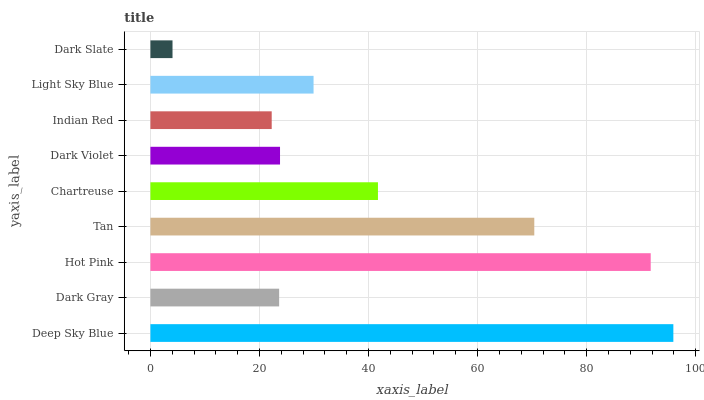Is Dark Slate the minimum?
Answer yes or no. Yes. Is Deep Sky Blue the maximum?
Answer yes or no. Yes. Is Dark Gray the minimum?
Answer yes or no. No. Is Dark Gray the maximum?
Answer yes or no. No. Is Deep Sky Blue greater than Dark Gray?
Answer yes or no. Yes. Is Dark Gray less than Deep Sky Blue?
Answer yes or no. Yes. Is Dark Gray greater than Deep Sky Blue?
Answer yes or no. No. Is Deep Sky Blue less than Dark Gray?
Answer yes or no. No. Is Light Sky Blue the high median?
Answer yes or no. Yes. Is Light Sky Blue the low median?
Answer yes or no. Yes. Is Indian Red the high median?
Answer yes or no. No. Is Dark Gray the low median?
Answer yes or no. No. 